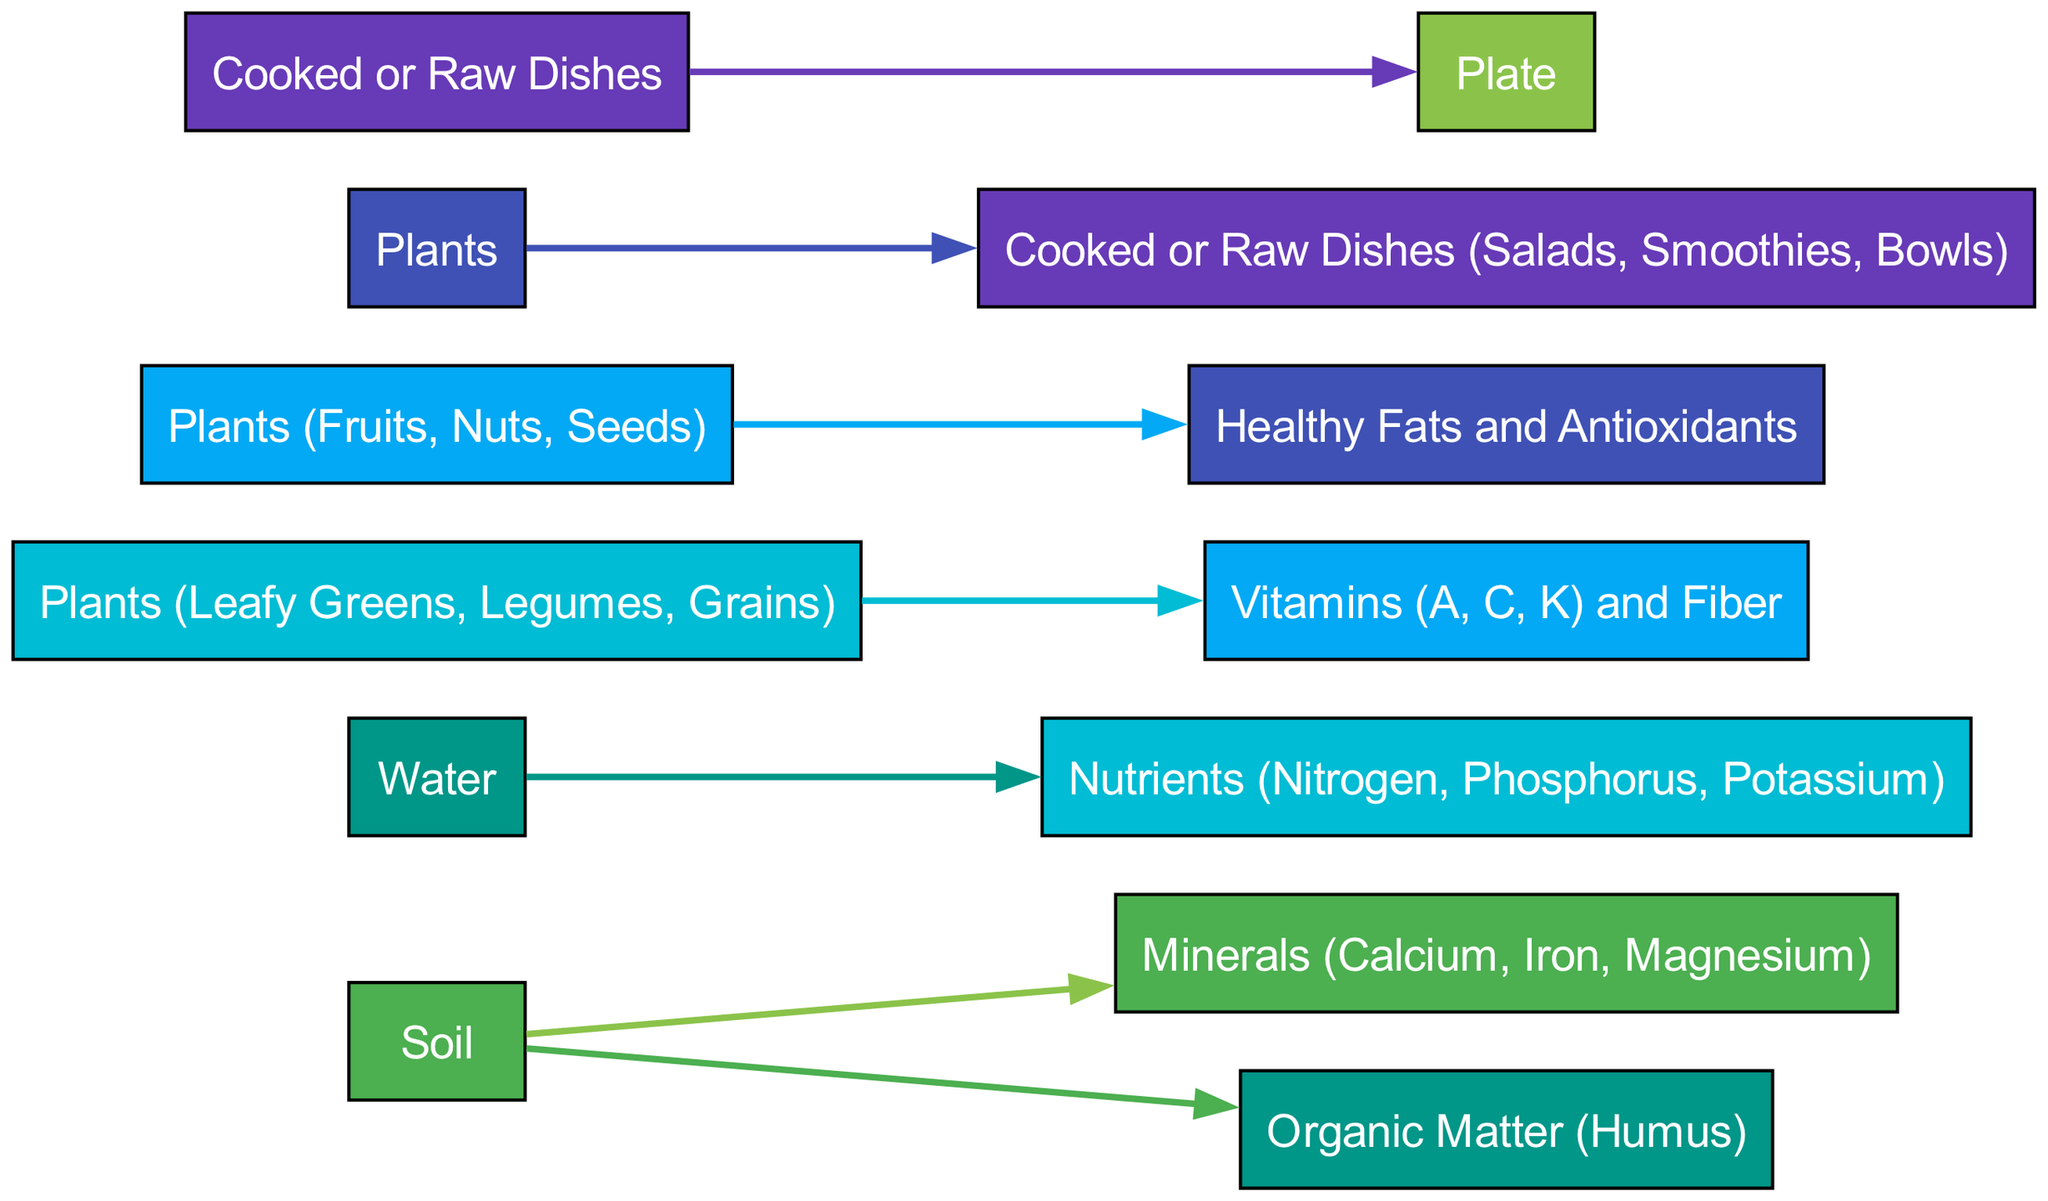What are the main sources of nutrients in a plant-based diet? The two main sources of nutrients depicted in the diagram are "Soil" and "Water". These sources provide essential elements that plants need to grow and thrive.
Answer: Soil and Water How many categories of nutrients do plants provide? The diagram specifies two categories of nutrients provided by plants: "Vitamins (A, C, K) and Fiber" and "Healthy Fats and Antioxidants". Therefore, there are two distinct categories.
Answer: Two Which plant categories are mentioned in the diagram for nutrient transfer? The diagram mentions two specific plant categories for nutrient transfer: "Leafy Greens, Legumes, Grains" and "Fruits, Nuts, Seeds". These are the plants that deliver nutrients to the dishes.
Answer: Leafy Greens, Legumes, Grains and Fruits, Nuts, Seeds What is the ultimate destination for nutrients in the diagram? The journey of nutrients ends at the "Plate", which is indicated as the final destination in the flow of nutrients from the sources through various stages.
Answer: Plate How many edges are present in the diagram? Counting the connections between nodes, there are a total of six edges in the diagram that represent the flow from source to target.
Answer: Six What nutrient flows directly from water? The diagram indicates that "Nutrients (Nitrogen, Phosphorus, Potassium)" flow directly from "Water", showing this specific relationship in the nutrient cycle.
Answer: Nutrients (Nitrogen, Phosphorus, Potassium) Which process links plants to the final dishes? The diagram shows that "Plants" directly lead to "Cooked or Raw Dishes (Salads, Smoothies, Bowls)", indicating how plants are transformed into these food items.
Answer: Cooked or Raw Dishes What nutrients come from the soil? The diagram outlines that "Minerals (Calcium, Iron, Magnesium)" and "Organic Matter (Humus)" are the nutrients that come directly from "Soil".
Answer: Minerals (Calcium, Iron, Magnesium) and Organic Matter (Humus) How is the nutrient flow represented in the diagram? The diagram uses arrows to show the direction of nutrient flow from sources like soil and water to plants, then to dishes, visually representing the process.
Answer: Arrows 